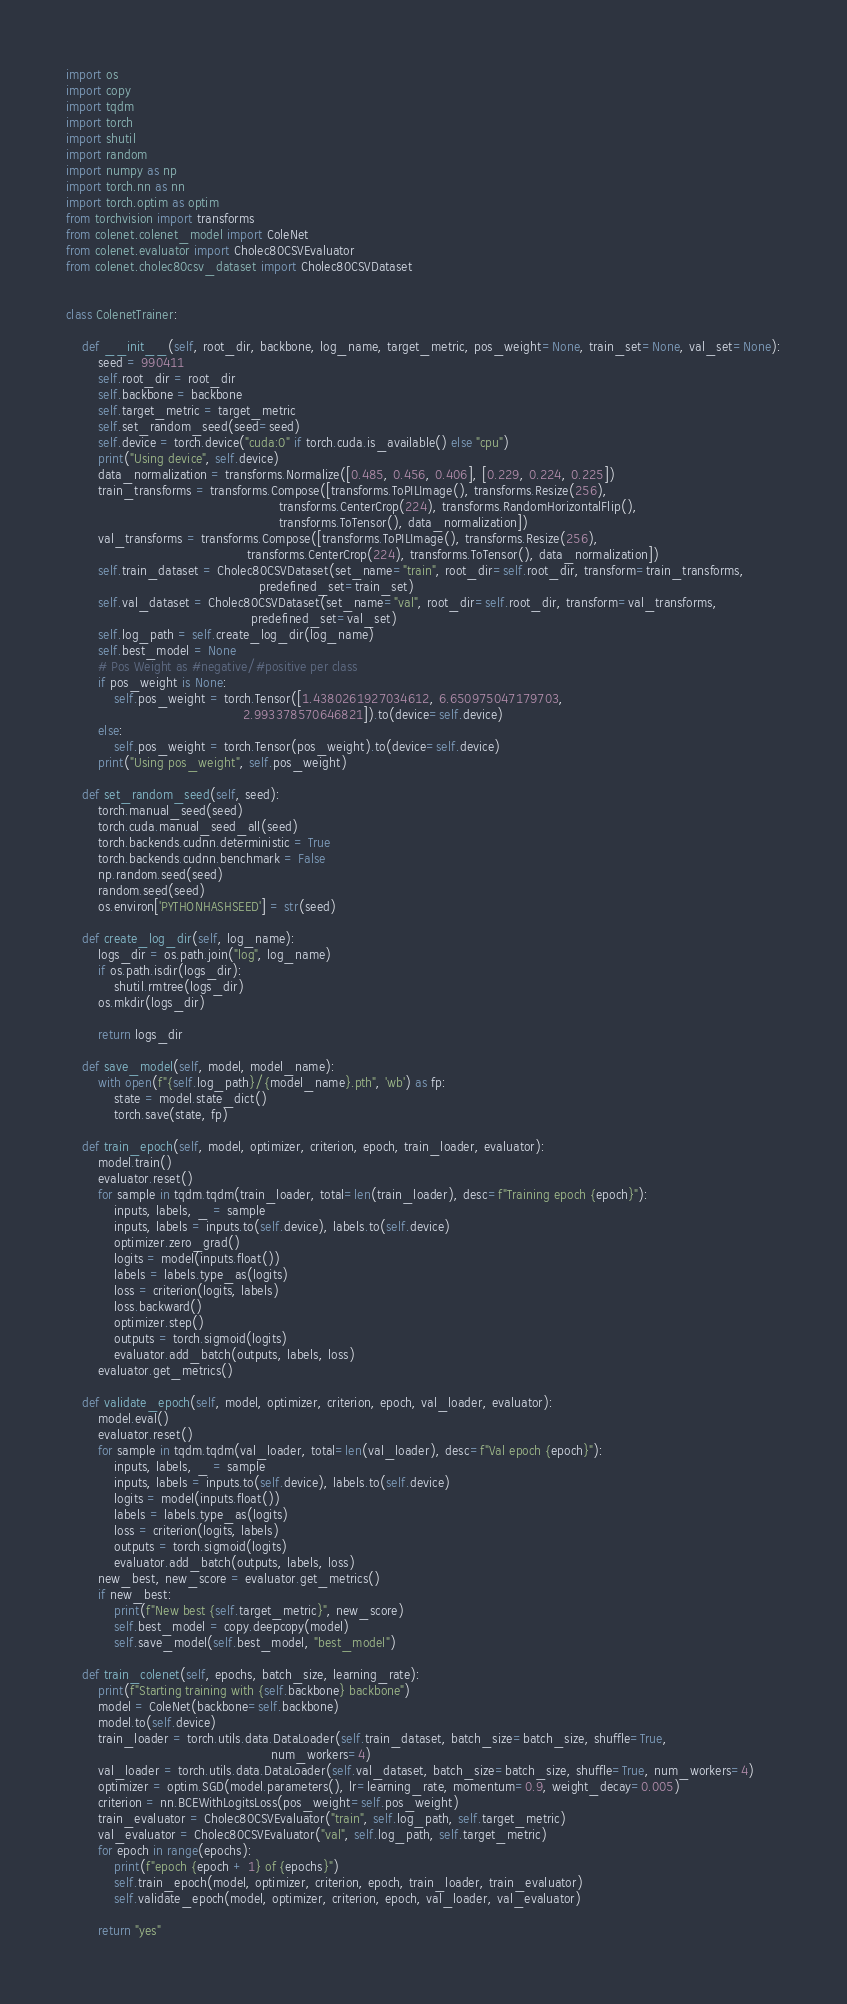Convert code to text. <code><loc_0><loc_0><loc_500><loc_500><_Python_>import os
import copy
import tqdm
import torch
import shutil
import random
import numpy as np
import torch.nn as nn
import torch.optim as optim
from torchvision import transforms
from colenet.colenet_model import ColeNet
from colenet.evaluator import Cholec80CSVEvaluator
from colenet.cholec80csv_dataset import Cholec80CSVDataset


class ColenetTrainer:

    def __init__(self, root_dir, backbone, log_name, target_metric, pos_weight=None, train_set=None, val_set=None):
        seed = 990411
        self.root_dir = root_dir
        self.backbone = backbone
        self.target_metric = target_metric
        self.set_random_seed(seed=seed)
        self.device = torch.device("cuda:0" if torch.cuda.is_available() else "cpu")
        print("Using device", self.device)
        data_normalization = transforms.Normalize([0.485, 0.456, 0.406], [0.229, 0.224, 0.225])
        train_transforms = transforms.Compose([transforms.ToPILImage(), transforms.Resize(256),
                                                     transforms.CenterCrop(224), transforms.RandomHorizontalFlip(),
                                                     transforms.ToTensor(), data_normalization])
        val_transforms = transforms.Compose([transforms.ToPILImage(), transforms.Resize(256),
                                             transforms.CenterCrop(224), transforms.ToTensor(), data_normalization])
        self.train_dataset = Cholec80CSVDataset(set_name="train", root_dir=self.root_dir, transform=train_transforms,
                                                predefined_set=train_set)
        self.val_dataset = Cholec80CSVDataset(set_name="val", root_dir=self.root_dir, transform=val_transforms,
                                              predefined_set=val_set)
        self.log_path = self.create_log_dir(log_name)
        self.best_model = None
        # Pos Weight as #negative/#positive per class
        if pos_weight is None:
            self.pos_weight = torch.Tensor([1.4380261927034612, 6.650975047179703,
                                            2.993378570646821]).to(device=self.device)
        else:
            self.pos_weight = torch.Tensor(pos_weight).to(device=self.device)
        print("Using pos_weight", self.pos_weight)

    def set_random_seed(self, seed):
        torch.manual_seed(seed)
        torch.cuda.manual_seed_all(seed)
        torch.backends.cudnn.deterministic = True
        torch.backends.cudnn.benchmark = False
        np.random.seed(seed)
        random.seed(seed)
        os.environ['PYTHONHASHSEED'] = str(seed)

    def create_log_dir(self, log_name):
        logs_dir = os.path.join("log", log_name)
        if os.path.isdir(logs_dir):
            shutil.rmtree(logs_dir)
        os.mkdir(logs_dir)

        return logs_dir

    def save_model(self, model, model_name):
        with open(f"{self.log_path}/{model_name}.pth", 'wb') as fp:
            state = model.state_dict()
            torch.save(state, fp)

    def train_epoch(self, model, optimizer, criterion, epoch, train_loader, evaluator):
        model.train()
        evaluator.reset()
        for sample in tqdm.tqdm(train_loader, total=len(train_loader), desc=f"Training epoch {epoch}"):
            inputs, labels, _ = sample
            inputs, labels = inputs.to(self.device), labels.to(self.device)
            optimizer.zero_grad()
            logits = model(inputs.float())
            labels = labels.type_as(logits)
            loss = criterion(logits, labels)
            loss.backward()
            optimizer.step()
            outputs = torch.sigmoid(logits)
            evaluator.add_batch(outputs, labels, loss)
        evaluator.get_metrics()

    def validate_epoch(self, model, optimizer, criterion, epoch, val_loader, evaluator):
        model.eval()
        evaluator.reset()
        for sample in tqdm.tqdm(val_loader, total=len(val_loader), desc=f"Val epoch {epoch}"):
            inputs, labels, _ = sample
            inputs, labels = inputs.to(self.device), labels.to(self.device)
            logits = model(inputs.float())
            labels = labels.type_as(logits)
            loss = criterion(logits, labels)
            outputs = torch.sigmoid(logits)
            evaluator.add_batch(outputs, labels, loss)
        new_best, new_score = evaluator.get_metrics()
        if new_best:
            print(f"New best {self.target_metric}", new_score)
            self.best_model = copy.deepcopy(model)
            self.save_model(self.best_model, "best_model")

    def train_colenet(self, epochs, batch_size, learning_rate):
        print(f"Starting training with {self.backbone} backbone")
        model = ColeNet(backbone=self.backbone)
        model.to(self.device)
        train_loader = torch.utils.data.DataLoader(self.train_dataset, batch_size=batch_size, shuffle=True,
                                                   num_workers=4)
        val_loader = torch.utils.data.DataLoader(self.val_dataset, batch_size=batch_size, shuffle=True, num_workers=4)
        optimizer = optim.SGD(model.parameters(), lr=learning_rate, momentum=0.9, weight_decay=0.005)
        criterion = nn.BCEWithLogitsLoss(pos_weight=self.pos_weight)
        train_evaluator = Cholec80CSVEvaluator("train", self.log_path, self.target_metric)
        val_evaluator = Cholec80CSVEvaluator("val", self.log_path, self.target_metric)
        for epoch in range(epochs):
            print(f"epoch {epoch + 1} of {epochs}")
            self.train_epoch(model, optimizer, criterion, epoch, train_loader, train_evaluator)
            self.validate_epoch(model, optimizer, criterion, epoch, val_loader, val_evaluator)

        return "yes"

</code> 